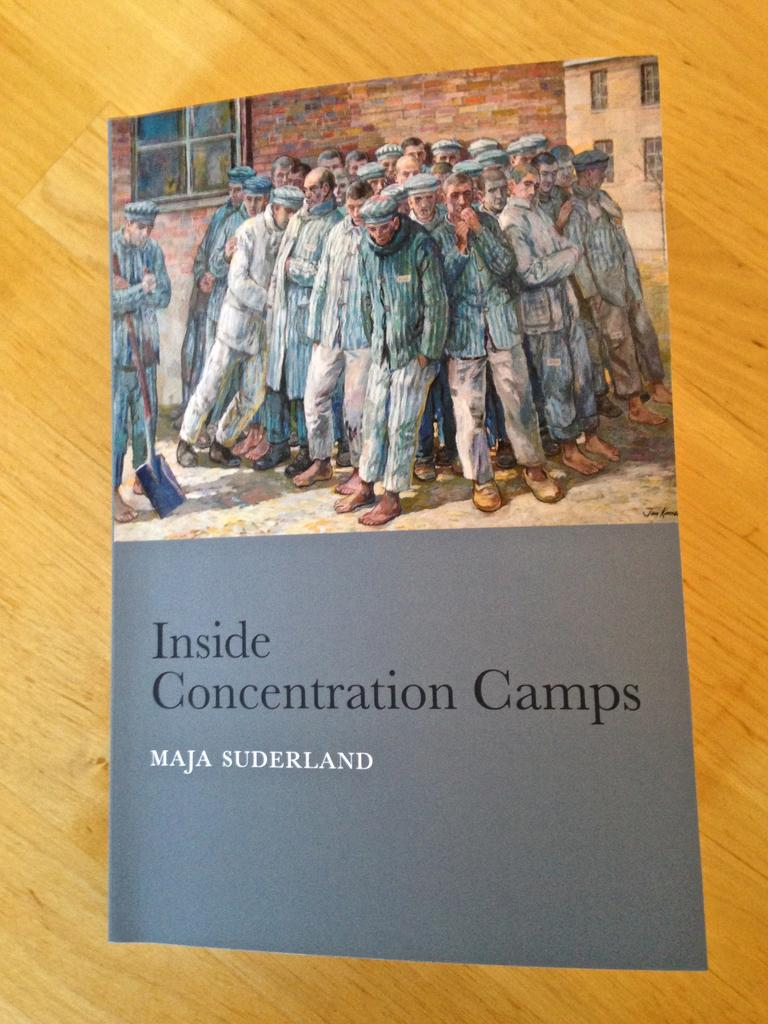What is the main object in the foreground of the image? There is a book in the foreground of the image. What is the book resting on? The book is on a wooden surface. What is depicted on the book? There is a painting of persons standing on the book. What can be seen at the bottom of the painting? There is text at the bottom of the painting. What type of insect can be seen crawling on the text at the bottom of the painting? There are no insects present in the image, and therefore no such activity can be observed. 